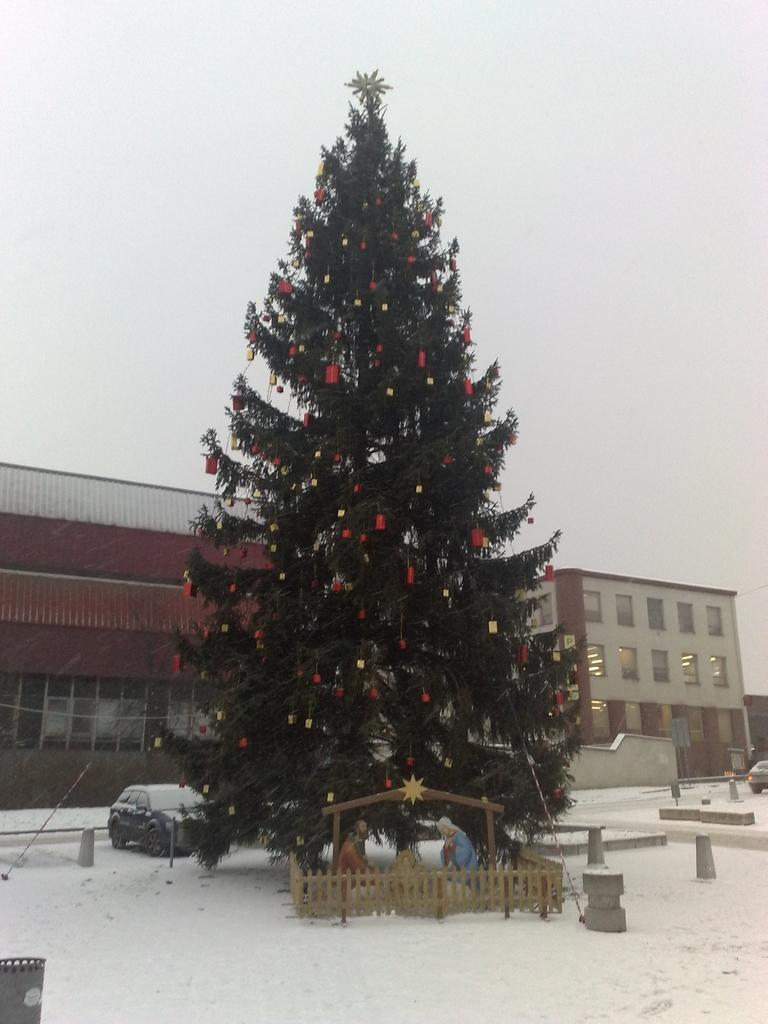Could you give a brief overview of what you see in this image? In the center of the image there is a christmas tree on the snow. In the background there are vehicles, buildings and sky. 